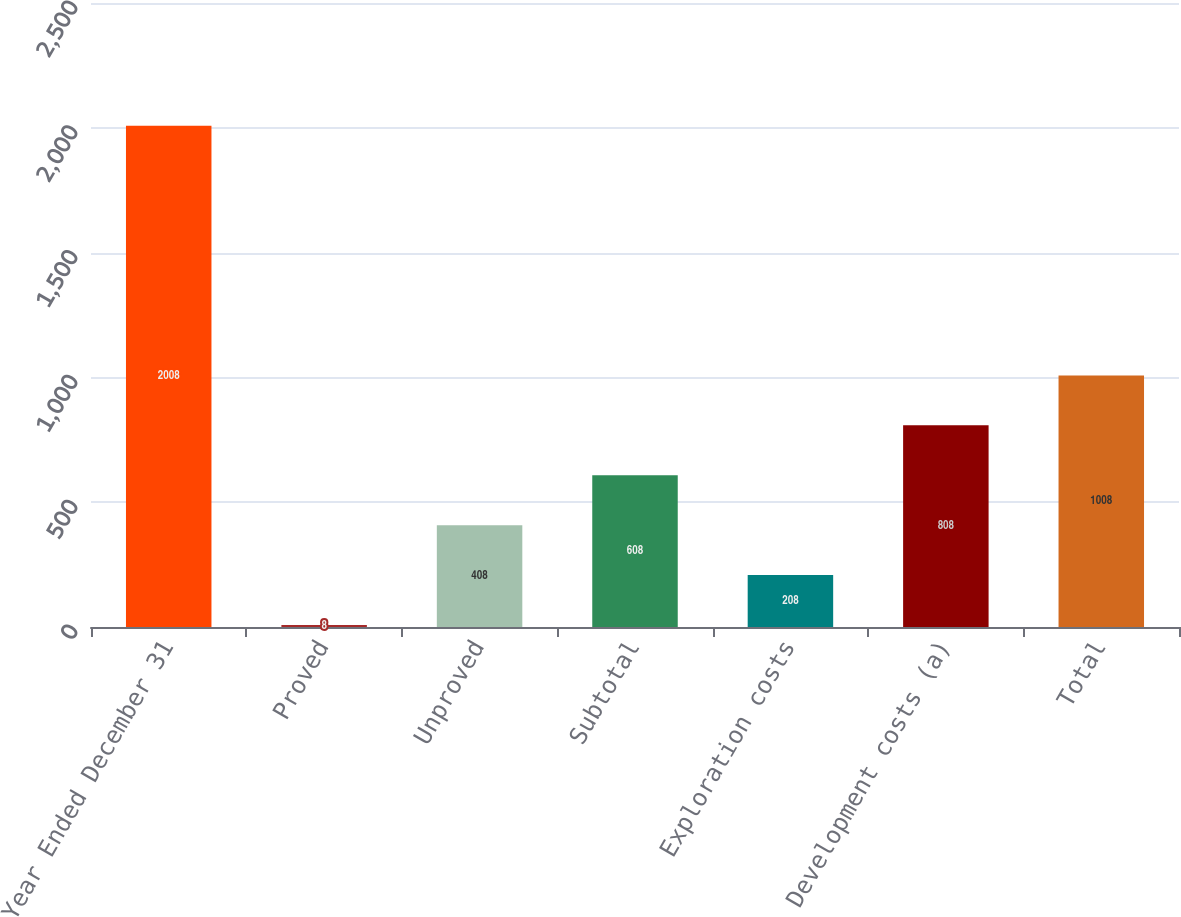Convert chart. <chart><loc_0><loc_0><loc_500><loc_500><bar_chart><fcel>Year Ended December 31<fcel>Proved<fcel>Unproved<fcel>Subtotal<fcel>Exploration costs<fcel>Development costs (a)<fcel>Total<nl><fcel>2008<fcel>8<fcel>408<fcel>608<fcel>208<fcel>808<fcel>1008<nl></chart> 